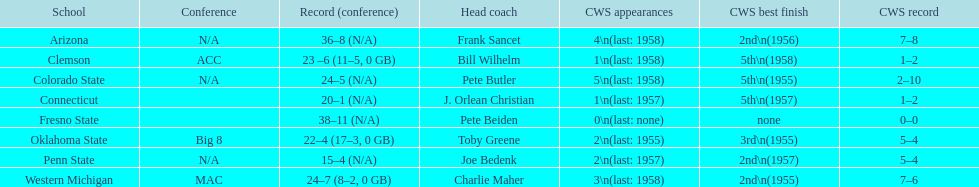What are all the schools? Arizona, Clemson, Colorado State, Connecticut, Fresno State, Oklahoma State, Penn State, Western Michigan. Which are clemson and western michigan? Clemson, Western Michigan. Of these, which has more cws appearances? Western Michigan. 